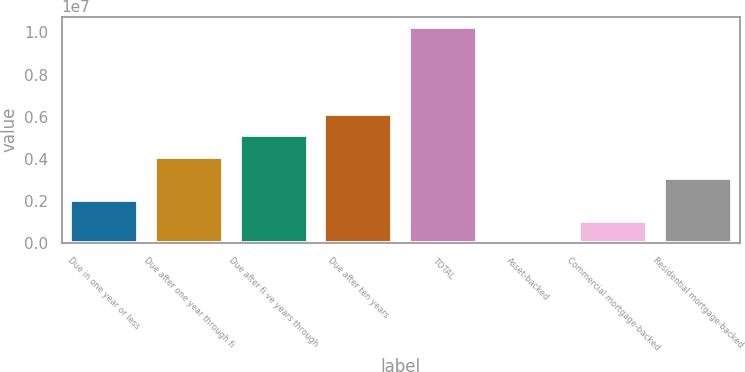<chart> <loc_0><loc_0><loc_500><loc_500><bar_chart><fcel>Due in one year or less<fcel>Due after one year through fi<fcel>Due after fi ve years through<fcel>Due after ten years<fcel>TOTAL<fcel>Asset-backed<fcel>Commercial mortgage-backed<fcel>Residential mortgage-backed<nl><fcel>2.053e+06<fcel>4.10048e+06<fcel>5.12422e+06<fcel>6.14796e+06<fcel>1.02429e+07<fcel>5519<fcel>1.02926e+06<fcel>3.07674e+06<nl></chart> 